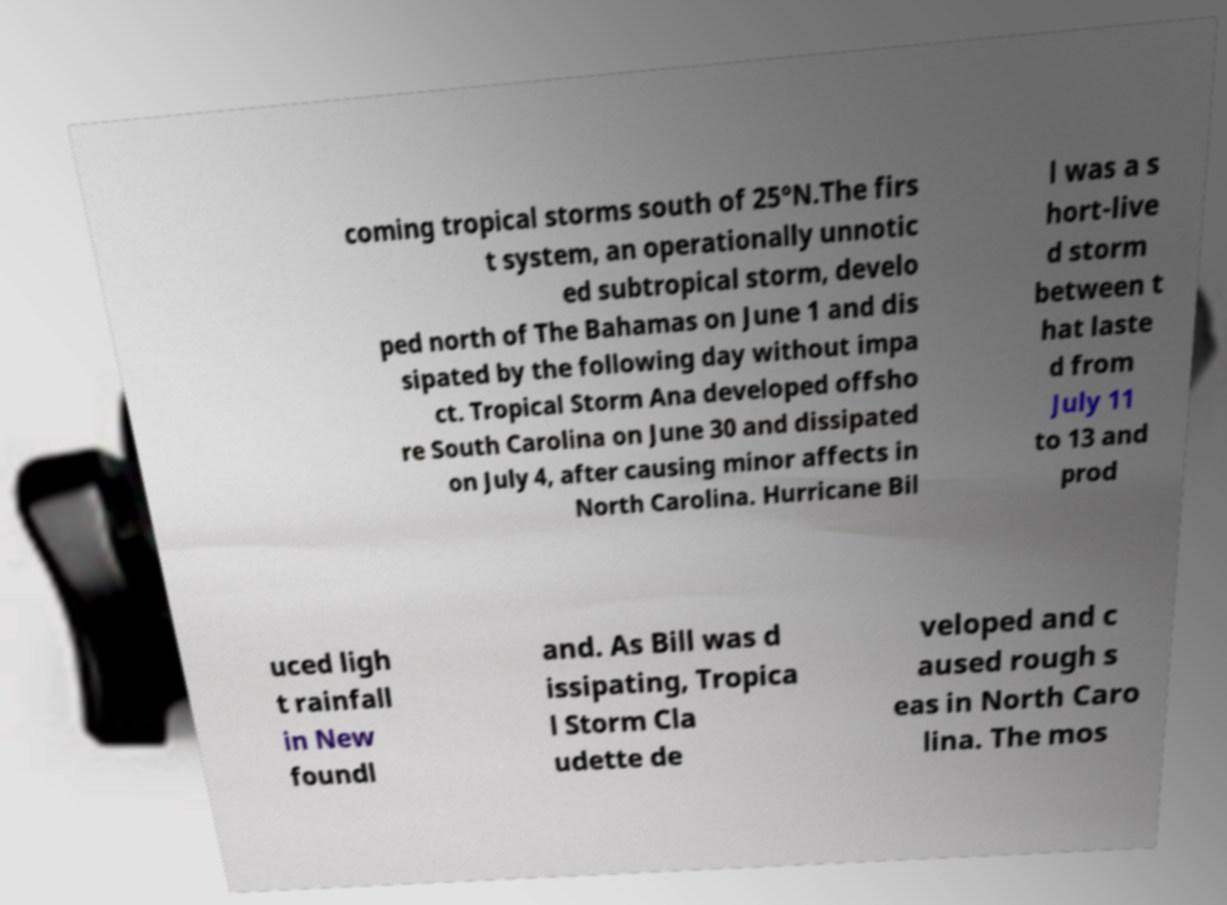For documentation purposes, I need the text within this image transcribed. Could you provide that? coming tropical storms south of 25°N.The firs t system, an operationally unnotic ed subtropical storm, develo ped north of The Bahamas on June 1 and dis sipated by the following day without impa ct. Tropical Storm Ana developed offsho re South Carolina on June 30 and dissipated on July 4, after causing minor affects in North Carolina. Hurricane Bil l was a s hort-live d storm between t hat laste d from July 11 to 13 and prod uced ligh t rainfall in New foundl and. As Bill was d issipating, Tropica l Storm Cla udette de veloped and c aused rough s eas in North Caro lina. The mos 